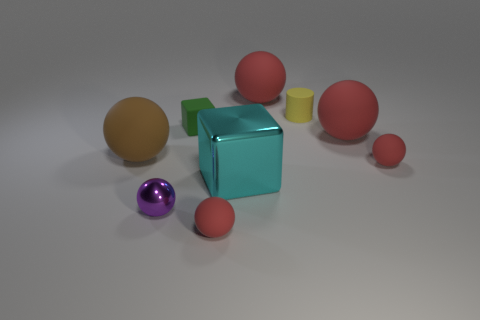Subtract all brown rubber spheres. How many spheres are left? 5 Subtract all cyan cylinders. How many red balls are left? 4 Add 1 shiny spheres. How many objects exist? 10 Subtract all brown balls. How many balls are left? 5 Subtract all cylinders. How many objects are left? 8 Subtract 4 balls. How many balls are left? 2 Subtract all large matte objects. Subtract all matte cylinders. How many objects are left? 5 Add 7 cyan objects. How many cyan objects are left? 8 Add 3 tiny purple balls. How many tiny purple balls exist? 4 Subtract 1 brown spheres. How many objects are left? 8 